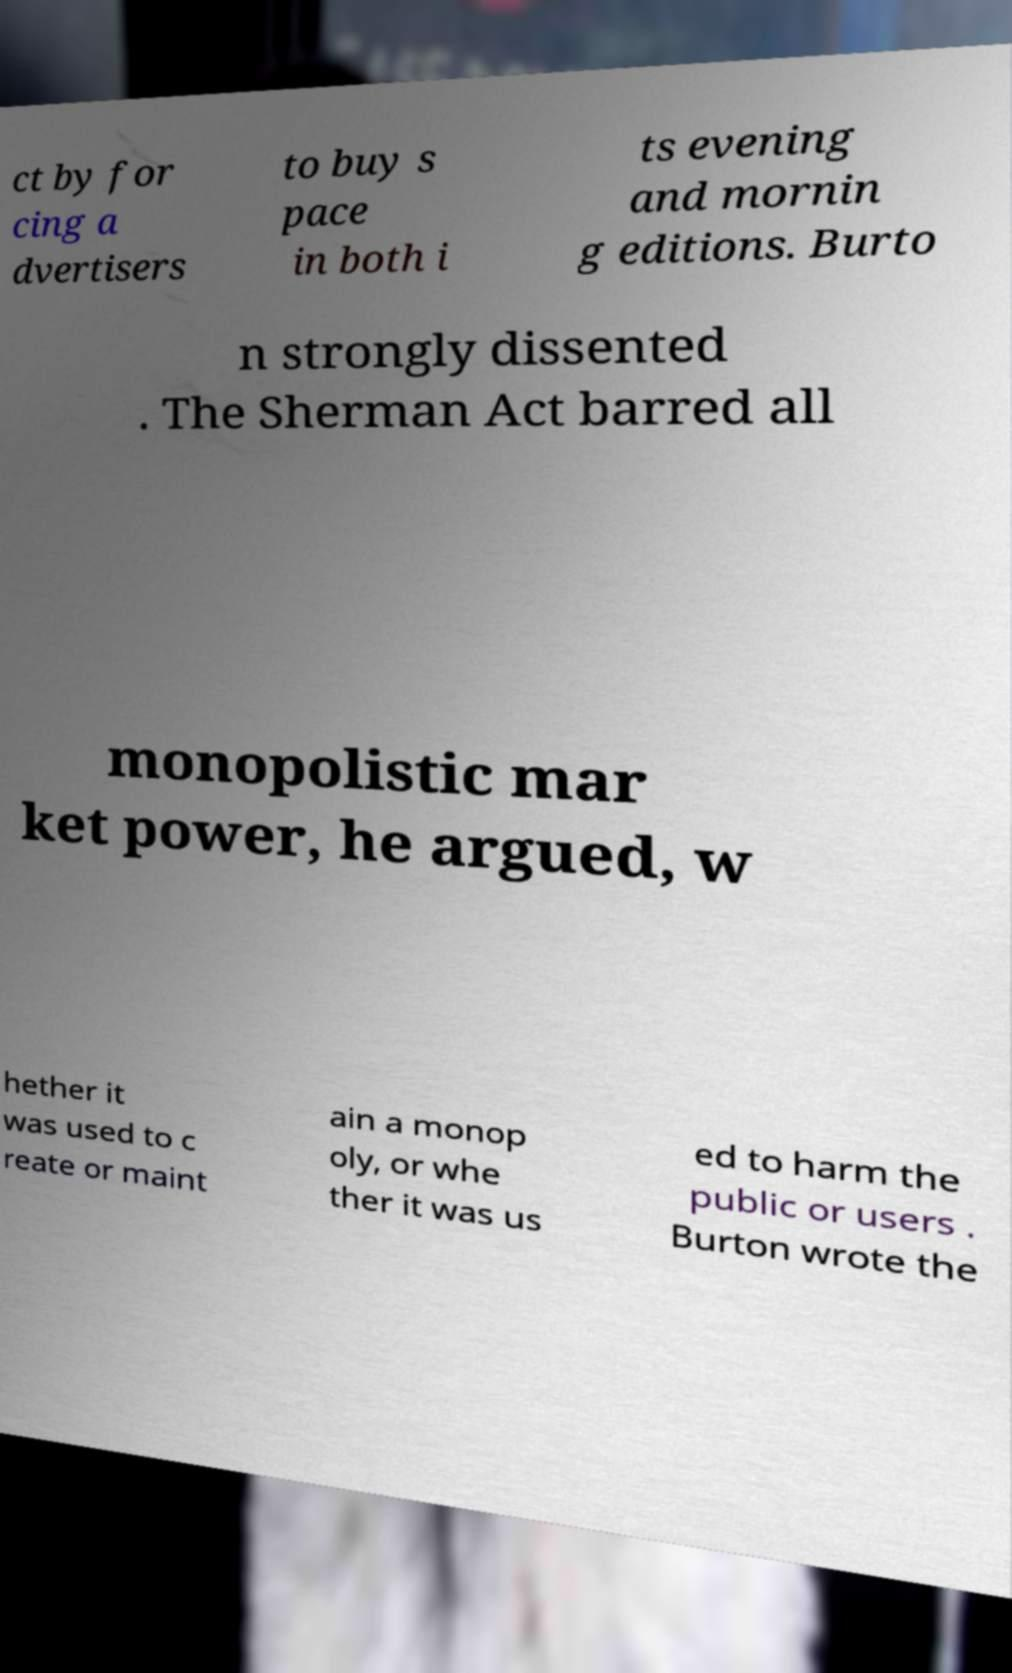Please identify and transcribe the text found in this image. ct by for cing a dvertisers to buy s pace in both i ts evening and mornin g editions. Burto n strongly dissented . The Sherman Act barred all monopolistic mar ket power, he argued, w hether it was used to c reate or maint ain a monop oly, or whe ther it was us ed to harm the public or users . Burton wrote the 